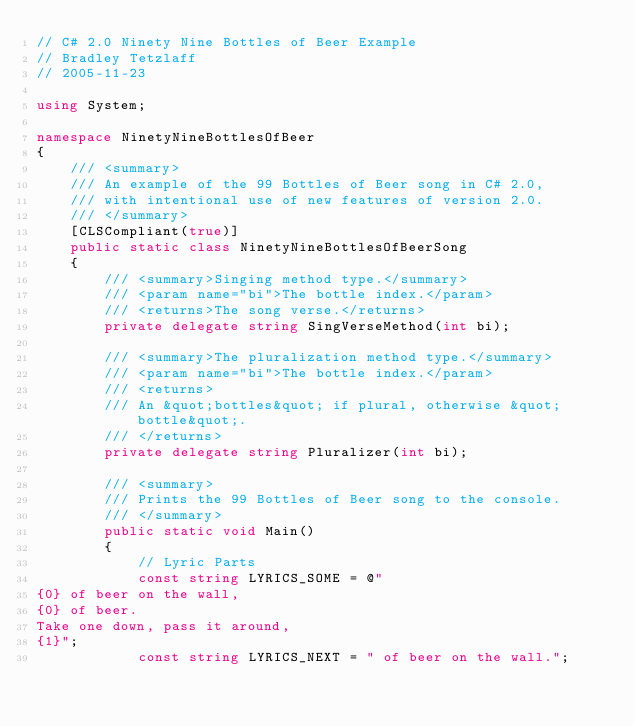<code> <loc_0><loc_0><loc_500><loc_500><_C#_>// C# 2.0 Ninety Nine Bottles of Beer Example
// Bradley Tetzlaff
// 2005-11-23

using System;

namespace NinetyNineBottlesOfBeer
{
    /// <summary>
    /// An example of the 99 Bottles of Beer song in C# 2.0,
    /// with intentional use of new features of version 2.0.
    /// </summary>
    [CLSCompliant(true)]
    public static class NinetyNineBottlesOfBeerSong
    {
        /// <summary>Singing method type.</summary>
        /// <param name="bi">The bottle index.</param>
        /// <returns>The song verse.</returns>
        private delegate string SingVerseMethod(int bi);

        /// <summary>The pluralization method type.</summary>
        /// <param name="bi">The bottle index.</param>
        /// <returns>
        /// An &quot;bottles&quot; if plural, otherwise &quot;bottle&quot;.
        /// </returns>
        private delegate string Pluralizer(int bi);

        /// <summary>
        /// Prints the 99 Bottles of Beer song to the console.
        /// </summary>
        public static void Main()
        {
            // Lyric Parts
            const string LYRICS_SOME = @"
{0} of beer on the wall,
{0} of beer.
Take one down, pass it around,
{1}";
            const string LYRICS_NEXT = " of beer on the wall.";</code> 